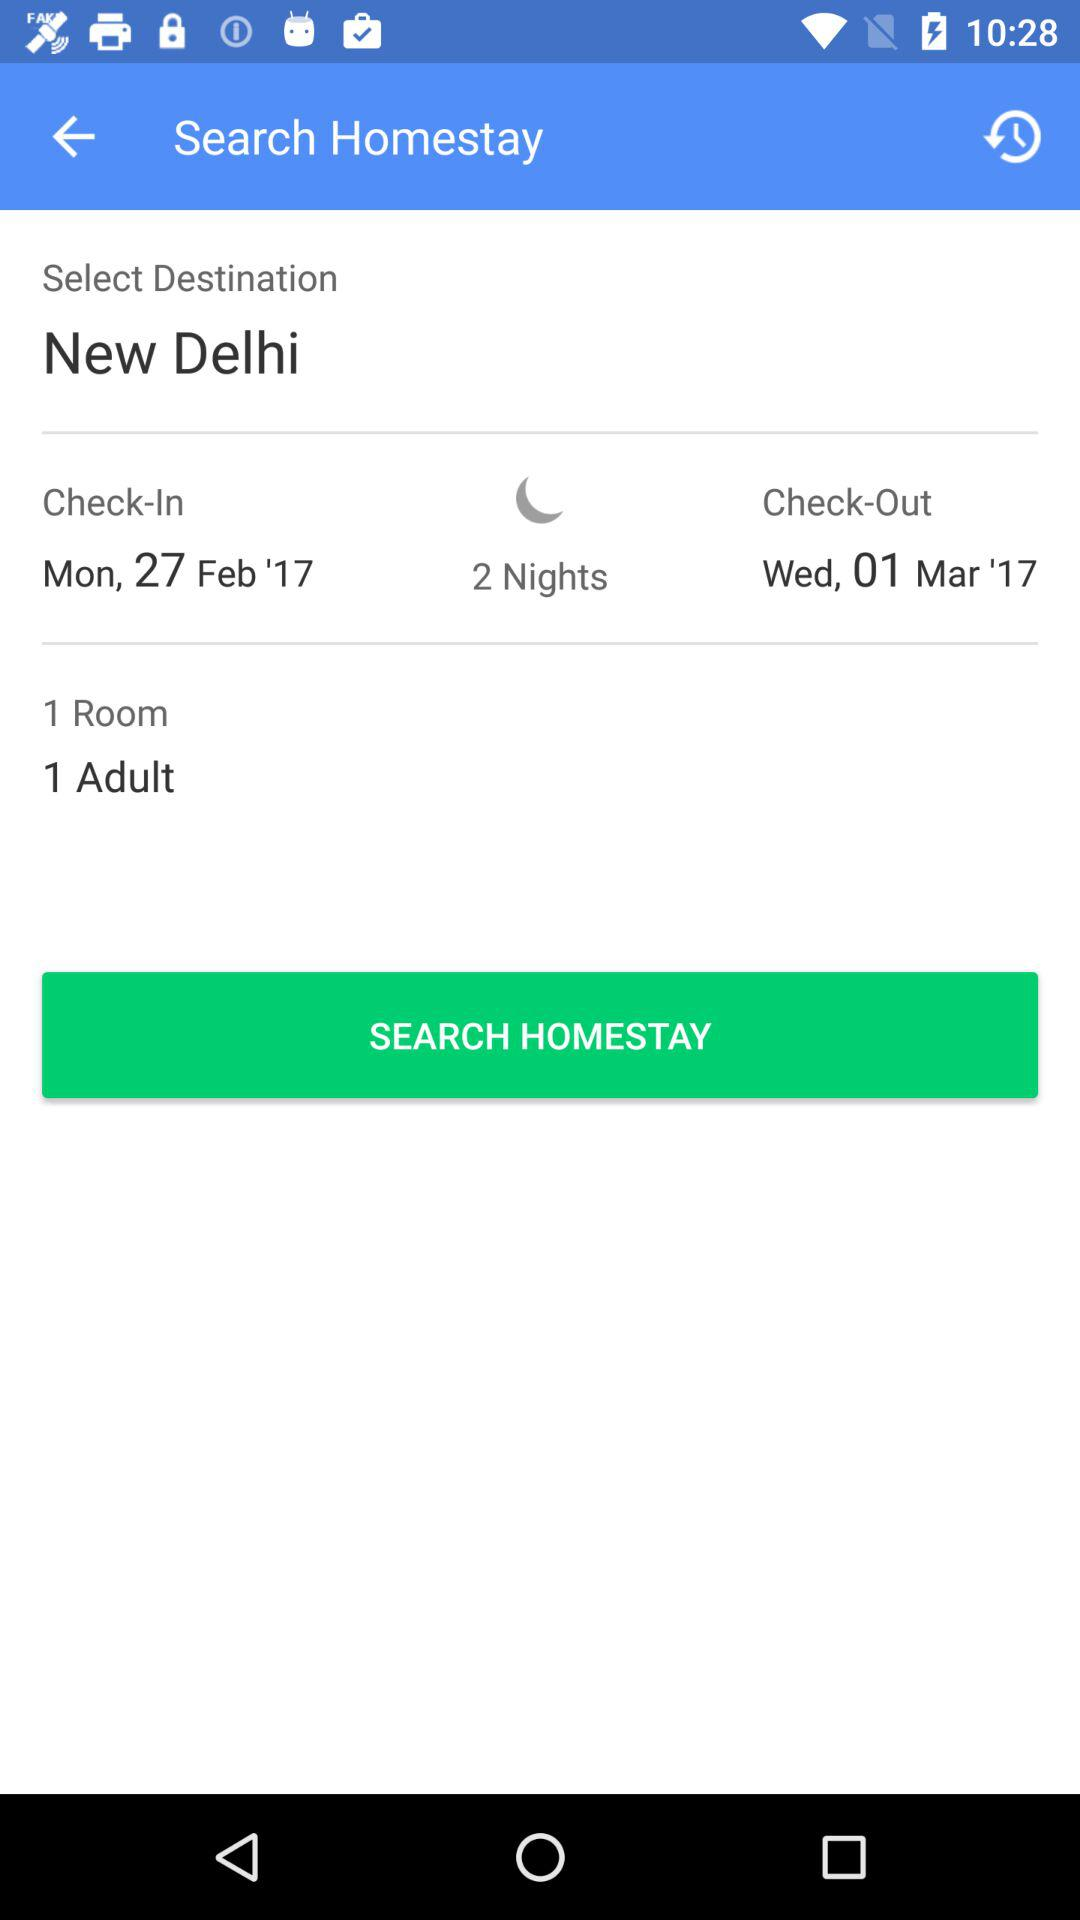How many adults are staying?
Answer the question using a single word or phrase. 1 